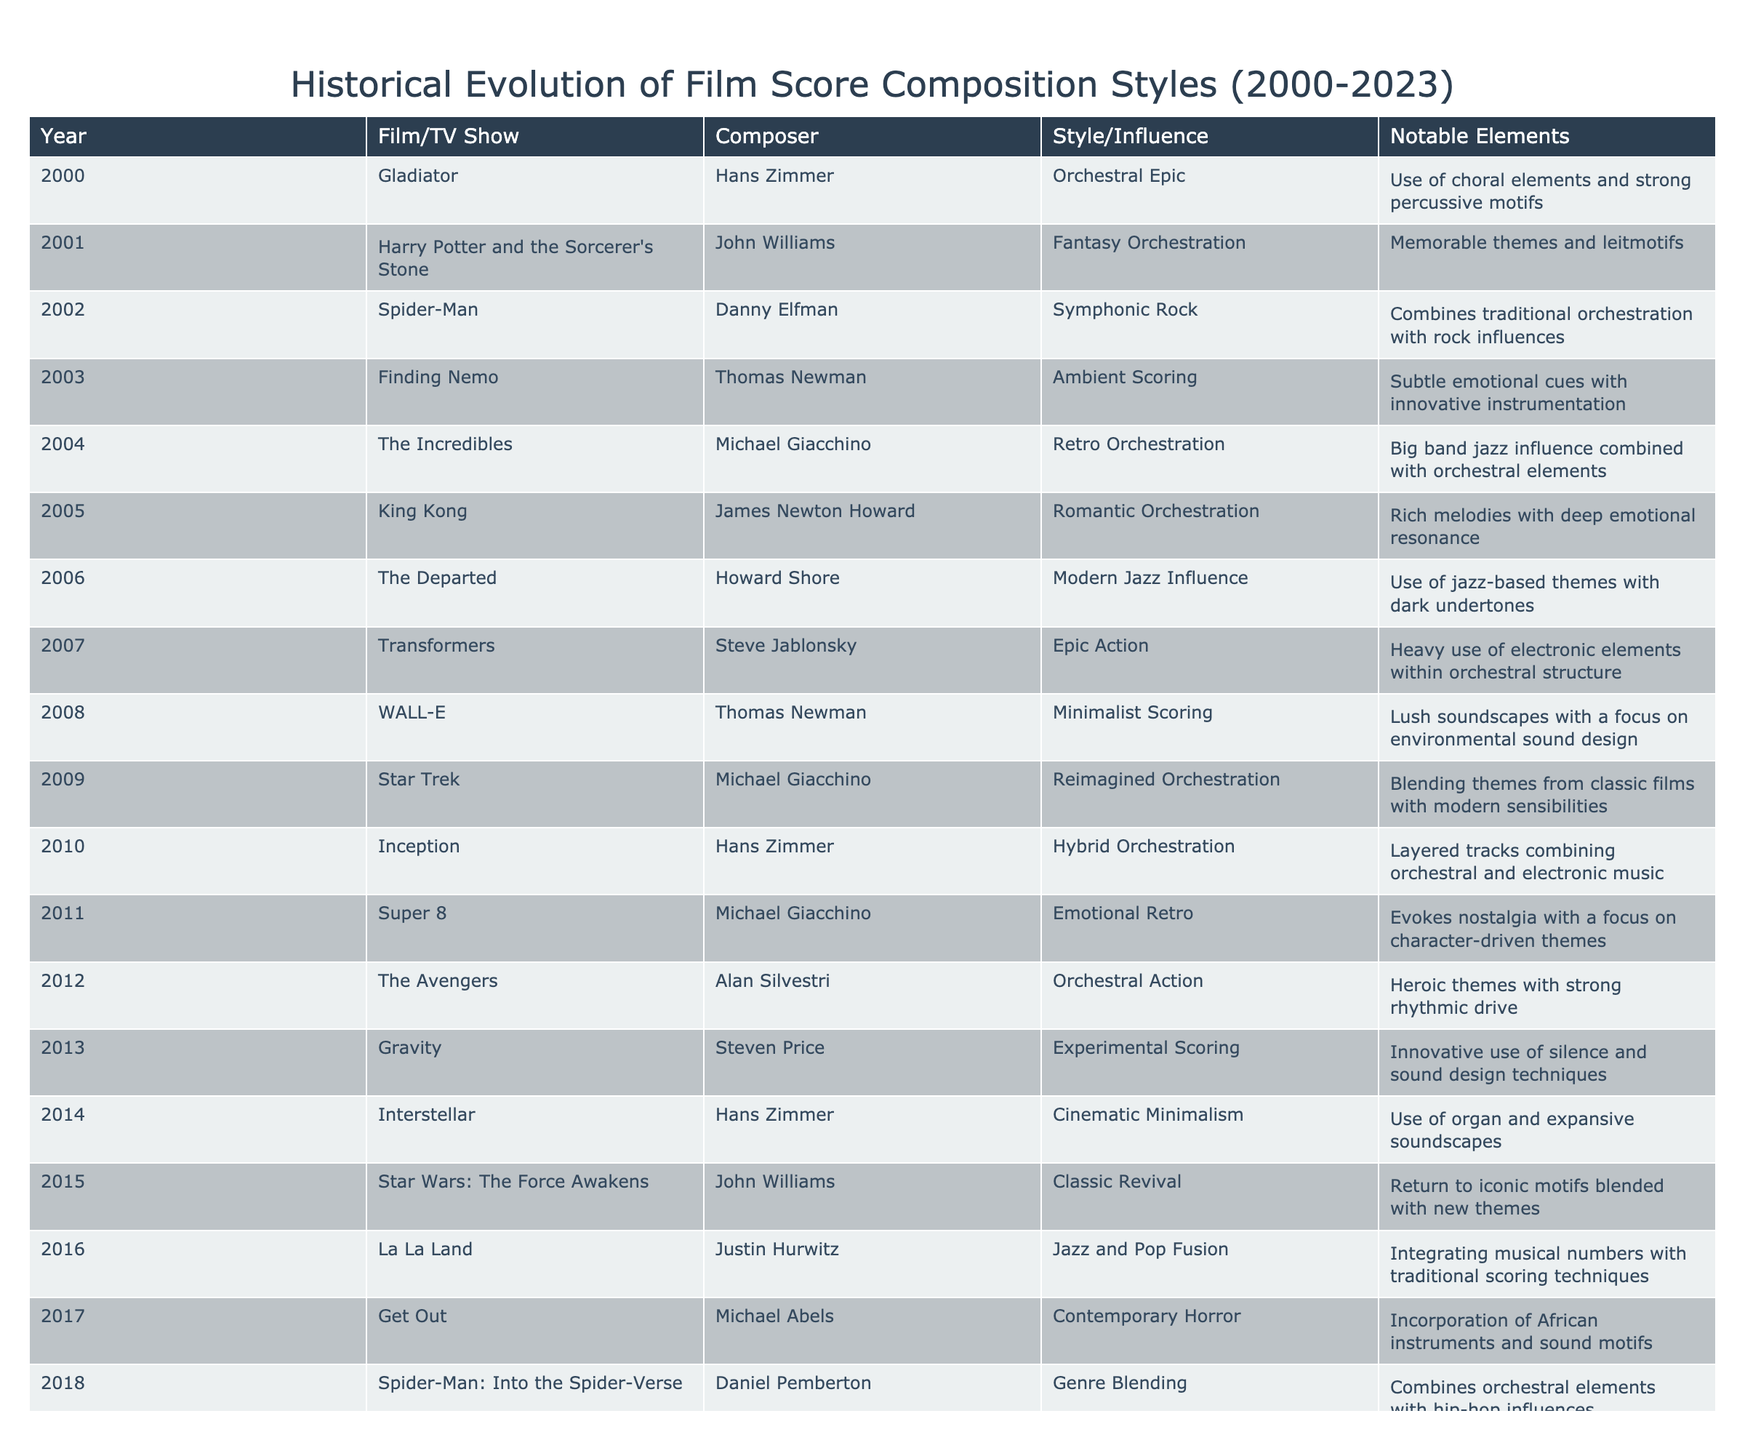What film had the orchestral epic style in 2000? The table lists "Gladiator" by Hans Zimmer as having the orchestral epic style in the year 2000.
Answer: Gladiator Which composer is associated with the film "Inception" released in 2010? The table indicates that Hans Zimmer composed the score for "Inception," which was released in 2010.
Answer: Hans Zimmer How many films feature Michael Giacchino as a composer? By counting the rows where Michael Giacchino is mentioned, there are three films: "The Incredibles" (2004), "Super 8" (2011), and "Star Trek" (2009).
Answer: Three Is there any film from 2018 that blends different musical genres? The table shows that "Spider-Man: Into the Spider-Verse," released in 2018 by Daniel Pemberton, combines orchestral elements with hip-hop influences.
Answer: Yes What musical style did John Williams adopt for "Star Wars: The Force Awakens" in 2015? According to the table, John Williams utilized the classic revival style for "Star Wars: The Force Awakens," returning to iconic motifs while blending in new themes.
Answer: Classic Revival How many films released from 2000 to 2023 feature orchestral scoring? Counting the entries labeled with orchestral-related styles gives us 11 films over the years mentioned in the table.
Answer: Eleven What notable element is common to both "Finding Nemo" and "WALL-E"? Both scores emphasize subtlety with innovative instrumentation, indicated by their respective styles (Ambient Scoring and Minimalist Scoring).
Answer: Subtle emotional cues Which composer's style transitioned from classic orchestration to cinematic minimalism, based on the table? The table shows that Hans Zimmer transitioned from orchestral epic style in 2000 to cinematic minimalism in "Interstellar" (2014).
Answer: Hans Zimmer How many composers used jazz influence in their scores from 2000 to 2023? The table identifies three composers: Howard Shore (Modern Jazz Influence in 2006), Justin Hurwitz (Jazz and Pop Fusion in 2016), and Michael Abels (using contemporary components in 2017).
Answer: Three What is the notable element of "Dune" by Hans Zimmer in 2021? "Dune" by Hans Zimmer is noted for the use of unconventional instruments and sound design, as mentioned in the table.
Answer: Unconventional instruments and sound design What style does "Everything Everywhere All At Once" reflect in 2022? The table classifies "Everything Everywhere All At Once" as eclectic scoring, integrating diverse cultural influences and styles.
Answer: Eclectic Scoring Between which years did Michael Giacchino compose scores for animated movies? The table shows Michael Giacchino composing for animated films from 2004 (The Incredibles) to 2019 (Toy Story 4).
Answer: 2004 to 2019 